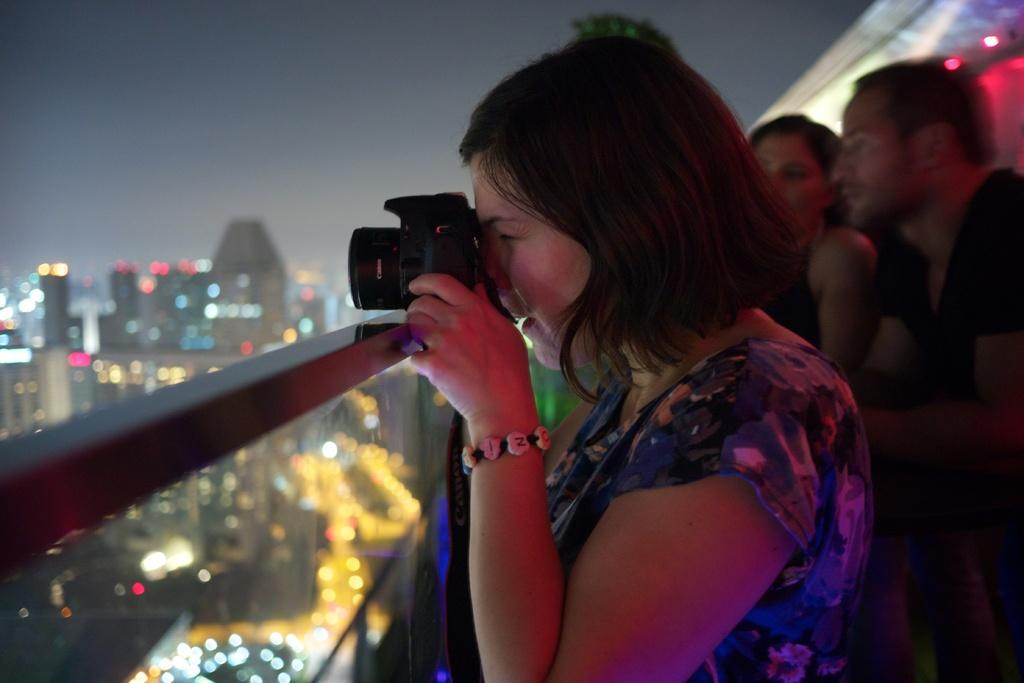What is the primary subject of the image? There is a woman standing in the image. What is the woman doing in the image? The woman is looking at the camera. Can you describe the background of the image? There are people in the background of the image. What is visible at the top of the image? The sky is visible at the top of the image. How many grapes can be seen on the woman's leg in the image? There are no grapes or legs visible in the image; it features a woman standing and looking at the camera. 